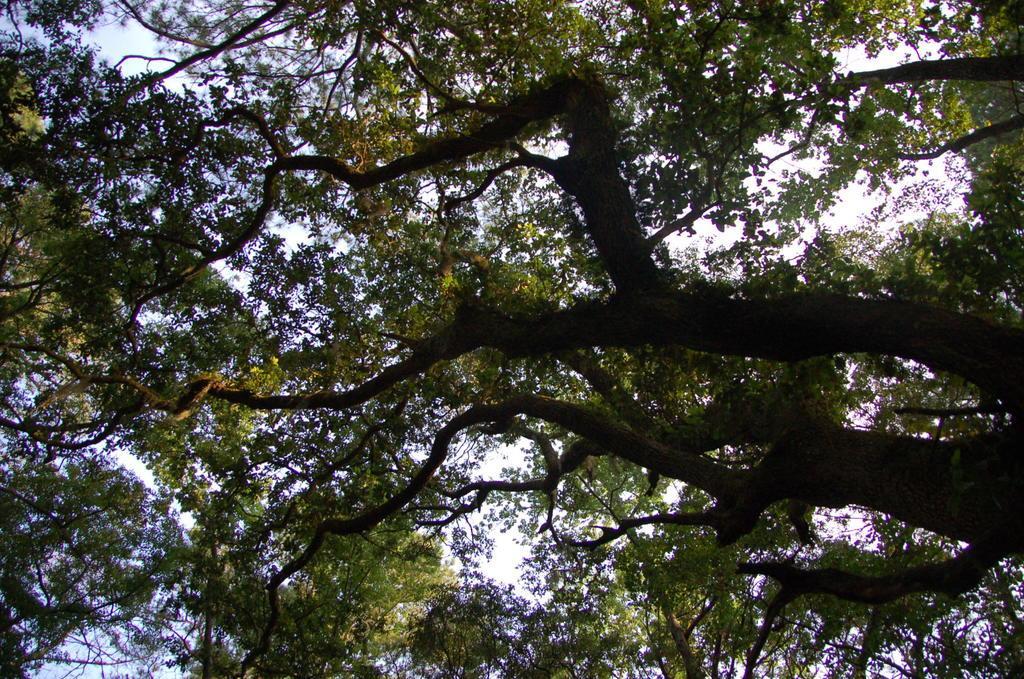Can you describe this image briefly? In this image we can see some trees and in the background there is a sky. 